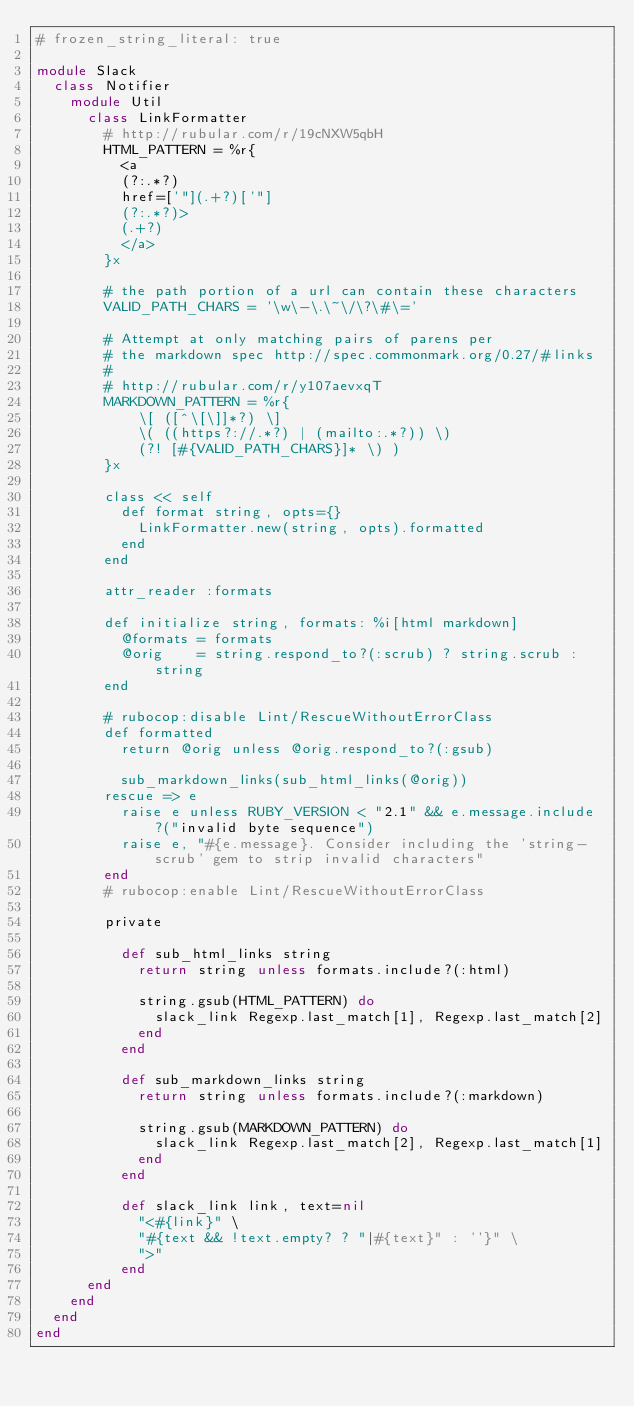Convert code to text. <code><loc_0><loc_0><loc_500><loc_500><_Ruby_># frozen_string_literal: true

module Slack
  class Notifier
    module Util
      class LinkFormatter
        # http://rubular.com/r/19cNXW5qbH
        HTML_PATTERN = %r{
          <a
          (?:.*?)
          href=['"](.+?)['"]
          (?:.*?)>
          (.+?)
          </a>
        }x

        # the path portion of a url can contain these characters
        VALID_PATH_CHARS = '\w\-\.\~\/\?\#\='

        # Attempt at only matching pairs of parens per
        # the markdown spec http://spec.commonmark.org/0.27/#links
        #
        # http://rubular.com/r/y107aevxqT
        MARKDOWN_PATTERN = %r{
            \[ ([^\[\]]*?) \]
            \( ((https?://.*?) | (mailto:.*?)) \)
            (?! [#{VALID_PATH_CHARS}]* \) )
        }x

        class << self
          def format string, opts={}
            LinkFormatter.new(string, opts).formatted
          end
        end

        attr_reader :formats

        def initialize string, formats: %i[html markdown]
          @formats = formats
          @orig    = string.respond_to?(:scrub) ? string.scrub : string
        end

        # rubocop:disable Lint/RescueWithoutErrorClass
        def formatted
          return @orig unless @orig.respond_to?(:gsub)

          sub_markdown_links(sub_html_links(@orig))
        rescue => e
          raise e unless RUBY_VERSION < "2.1" && e.message.include?("invalid byte sequence")
          raise e, "#{e.message}. Consider including the 'string-scrub' gem to strip invalid characters"
        end
        # rubocop:enable Lint/RescueWithoutErrorClass

        private

          def sub_html_links string
            return string unless formats.include?(:html)

            string.gsub(HTML_PATTERN) do
              slack_link Regexp.last_match[1], Regexp.last_match[2]
            end
          end

          def sub_markdown_links string
            return string unless formats.include?(:markdown)

            string.gsub(MARKDOWN_PATTERN) do
              slack_link Regexp.last_match[2], Regexp.last_match[1]
            end
          end

          def slack_link link, text=nil
            "<#{link}" \
            "#{text && !text.empty? ? "|#{text}" : ''}" \
            ">"
          end
      end
    end
  end
end
</code> 